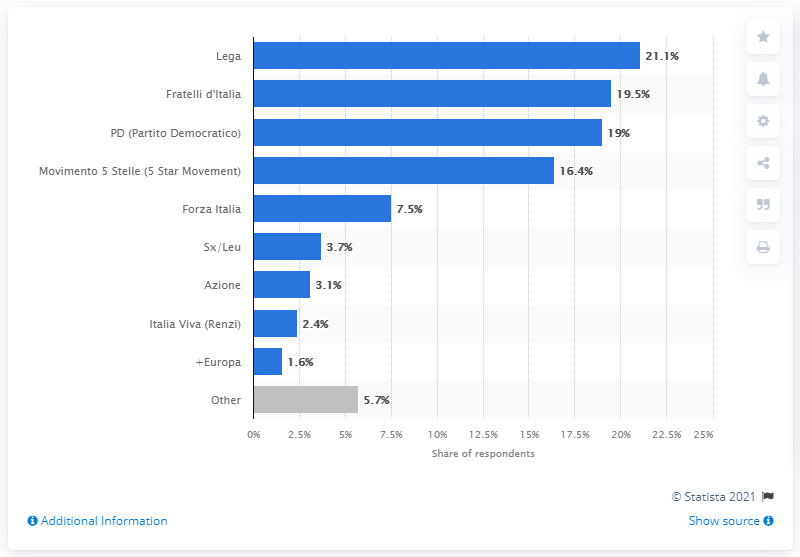Outline some significant characteristics in this image. The potential share of voters for Partito Democratico in 19.. was (amount). 